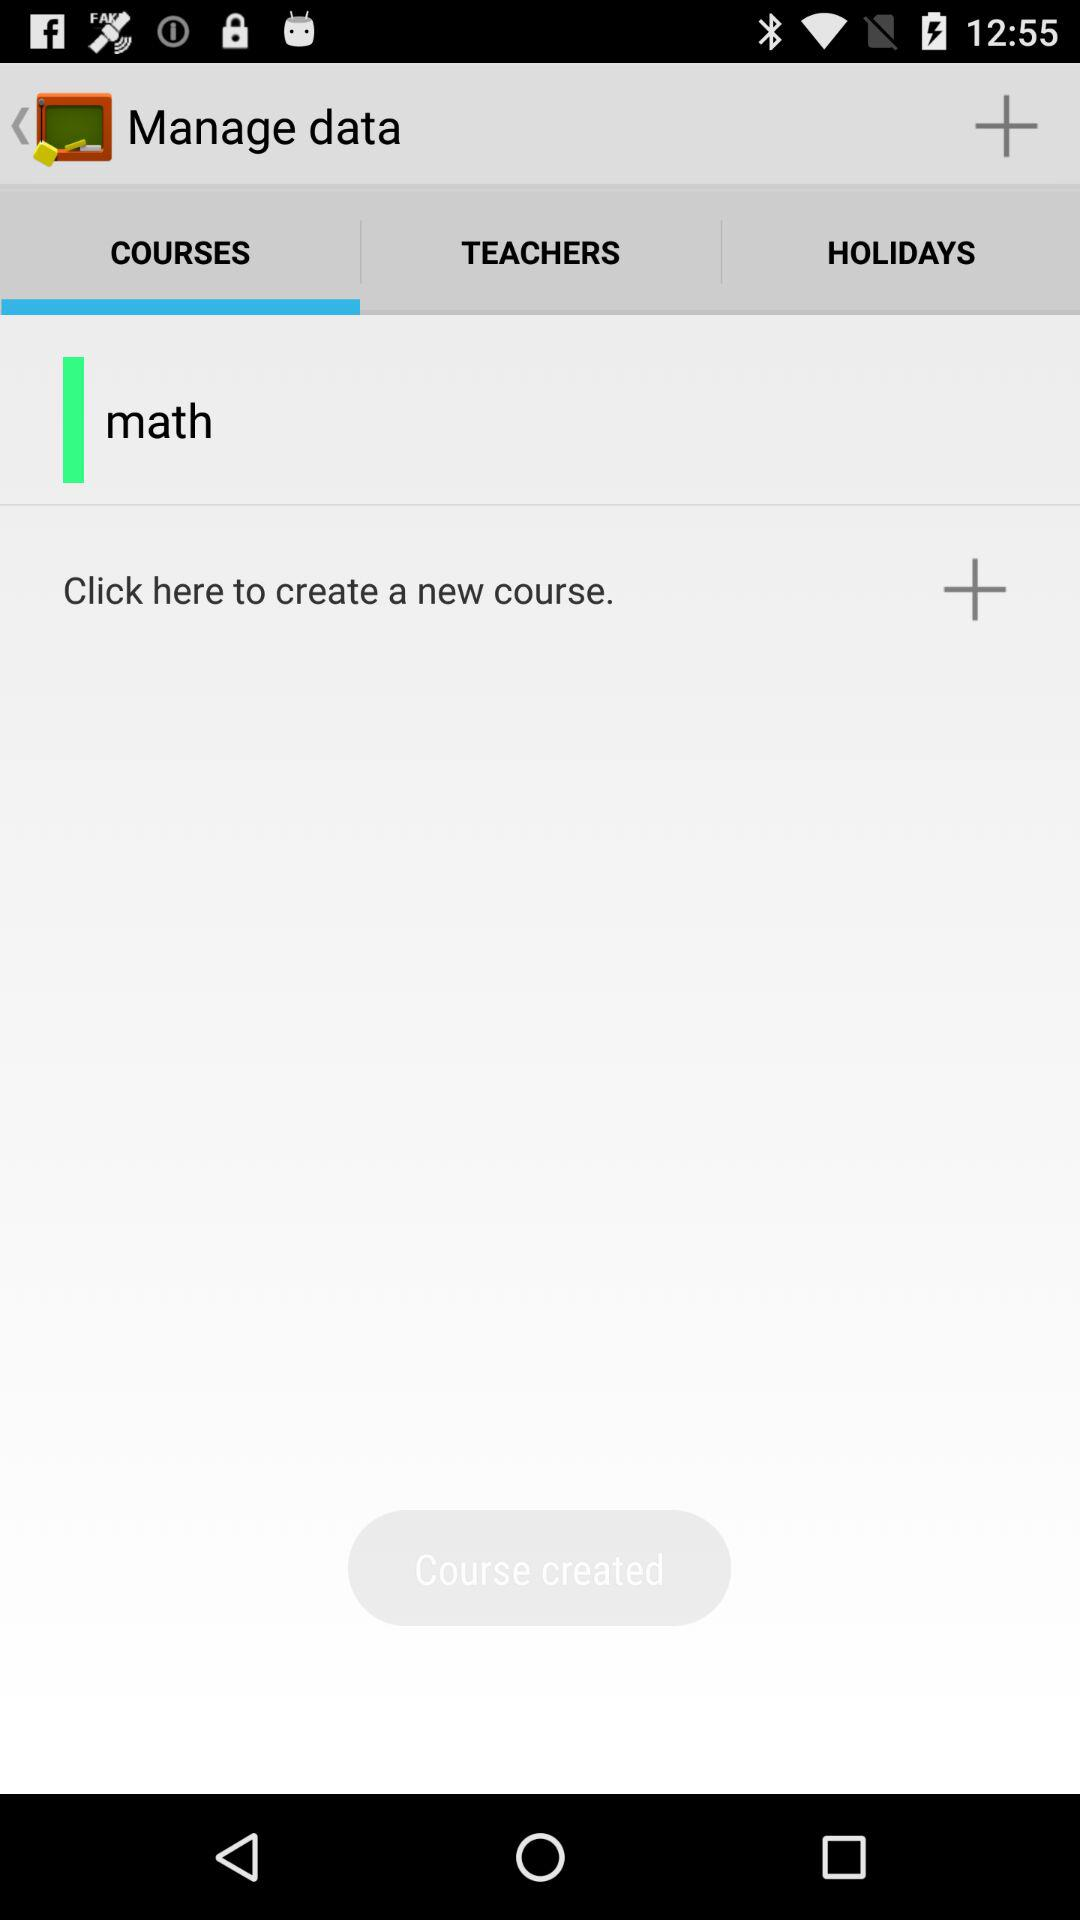What is the available course? The available course is "math". 